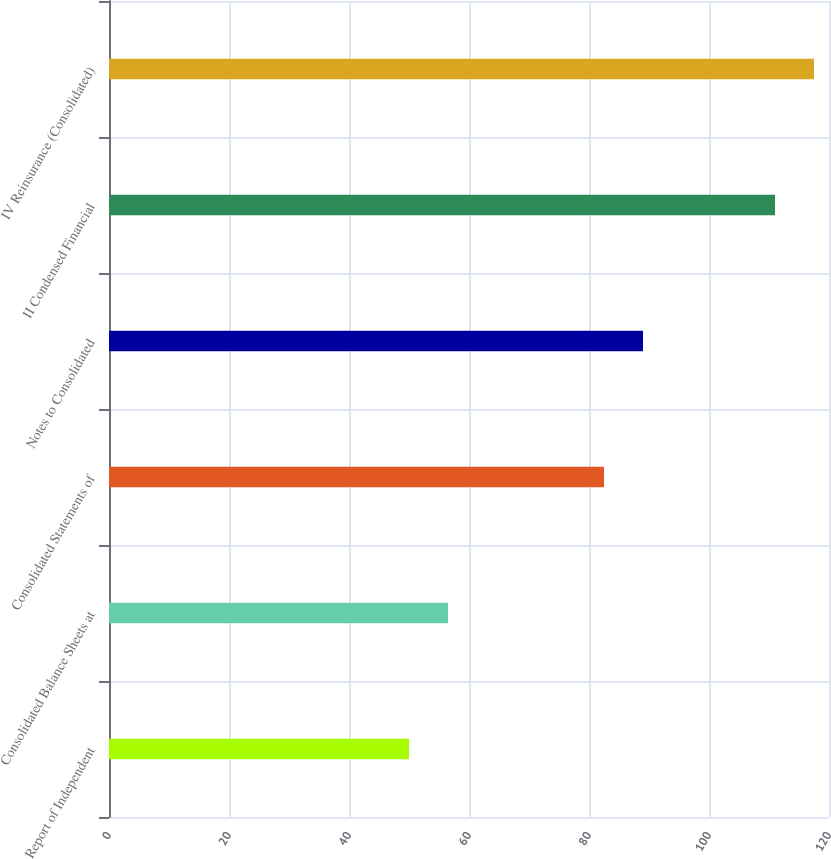<chart> <loc_0><loc_0><loc_500><loc_500><bar_chart><fcel>Report of Independent<fcel>Consolidated Balance Sheets at<fcel>Consolidated Statements of<fcel>Notes to Consolidated<fcel>II Condensed Financial<fcel>IV Reinsurance (Consolidated)<nl><fcel>50<fcel>56.5<fcel>82.5<fcel>89<fcel>111<fcel>117.5<nl></chart> 